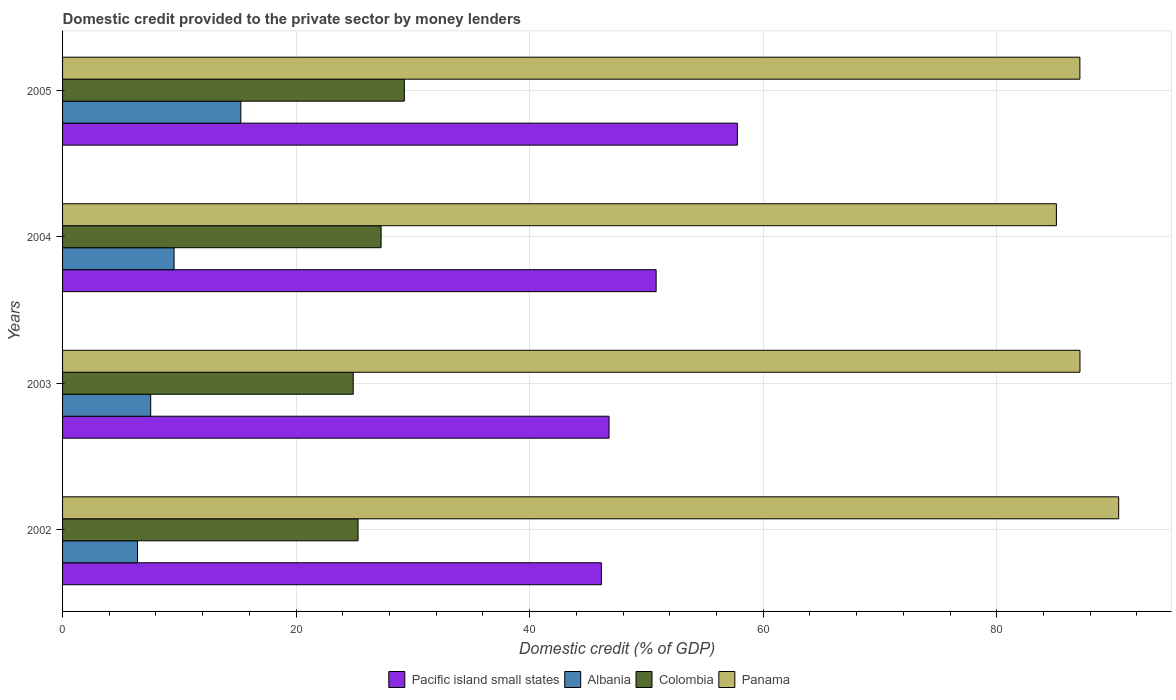How many groups of bars are there?
Make the answer very short. 4. How many bars are there on the 3rd tick from the bottom?
Ensure brevity in your answer.  4. In how many cases, is the number of bars for a given year not equal to the number of legend labels?
Provide a short and direct response. 0. What is the domestic credit provided to the private sector by money lenders in Panama in 2002?
Keep it short and to the point. 90.44. Across all years, what is the maximum domestic credit provided to the private sector by money lenders in Colombia?
Provide a succinct answer. 29.27. Across all years, what is the minimum domestic credit provided to the private sector by money lenders in Albania?
Offer a very short reply. 6.42. In which year was the domestic credit provided to the private sector by money lenders in Albania minimum?
Offer a terse response. 2002. What is the total domestic credit provided to the private sector by money lenders in Panama in the graph?
Give a very brief answer. 349.78. What is the difference between the domestic credit provided to the private sector by money lenders in Colombia in 2002 and that in 2003?
Provide a succinct answer. 0.41. What is the difference between the domestic credit provided to the private sector by money lenders in Pacific island small states in 2004 and the domestic credit provided to the private sector by money lenders in Albania in 2005?
Your response must be concise. 35.57. What is the average domestic credit provided to the private sector by money lenders in Pacific island small states per year?
Your answer should be compact. 50.39. In the year 2005, what is the difference between the domestic credit provided to the private sector by money lenders in Colombia and domestic credit provided to the private sector by money lenders in Albania?
Your answer should be very brief. 14. In how many years, is the domestic credit provided to the private sector by money lenders in Colombia greater than 88 %?
Your answer should be compact. 0. What is the ratio of the domestic credit provided to the private sector by money lenders in Colombia in 2003 to that in 2004?
Keep it short and to the point. 0.91. Is the domestic credit provided to the private sector by money lenders in Pacific island small states in 2004 less than that in 2005?
Your answer should be very brief. Yes. What is the difference between the highest and the second highest domestic credit provided to the private sector by money lenders in Albania?
Offer a very short reply. 5.71. What is the difference between the highest and the lowest domestic credit provided to the private sector by money lenders in Panama?
Keep it short and to the point. 5.33. In how many years, is the domestic credit provided to the private sector by money lenders in Colombia greater than the average domestic credit provided to the private sector by money lenders in Colombia taken over all years?
Offer a terse response. 2. Is it the case that in every year, the sum of the domestic credit provided to the private sector by money lenders in Panama and domestic credit provided to the private sector by money lenders in Pacific island small states is greater than the sum of domestic credit provided to the private sector by money lenders in Colombia and domestic credit provided to the private sector by money lenders in Albania?
Keep it short and to the point. Yes. What does the 4th bar from the top in 2003 represents?
Ensure brevity in your answer.  Pacific island small states. What does the 3rd bar from the bottom in 2004 represents?
Offer a terse response. Colombia. Is it the case that in every year, the sum of the domestic credit provided to the private sector by money lenders in Panama and domestic credit provided to the private sector by money lenders in Pacific island small states is greater than the domestic credit provided to the private sector by money lenders in Colombia?
Your answer should be very brief. Yes. How many years are there in the graph?
Provide a succinct answer. 4. Are the values on the major ticks of X-axis written in scientific E-notation?
Keep it short and to the point. No. Where does the legend appear in the graph?
Provide a succinct answer. Bottom center. How are the legend labels stacked?
Provide a short and direct response. Horizontal. What is the title of the graph?
Ensure brevity in your answer.  Domestic credit provided to the private sector by money lenders. What is the label or title of the X-axis?
Your answer should be compact. Domestic credit (% of GDP). What is the Domestic credit (% of GDP) in Pacific island small states in 2002?
Your answer should be compact. 46.14. What is the Domestic credit (% of GDP) in Albania in 2002?
Your response must be concise. 6.42. What is the Domestic credit (% of GDP) in Colombia in 2002?
Your response must be concise. 25.3. What is the Domestic credit (% of GDP) in Panama in 2002?
Provide a short and direct response. 90.44. What is the Domestic credit (% of GDP) in Pacific island small states in 2003?
Offer a very short reply. 46.8. What is the Domestic credit (% of GDP) in Albania in 2003?
Ensure brevity in your answer.  7.55. What is the Domestic credit (% of GDP) of Colombia in 2003?
Ensure brevity in your answer.  24.89. What is the Domestic credit (% of GDP) of Panama in 2003?
Offer a terse response. 87.12. What is the Domestic credit (% of GDP) in Pacific island small states in 2004?
Your answer should be very brief. 50.83. What is the Domestic credit (% of GDP) of Albania in 2004?
Your answer should be compact. 9.55. What is the Domestic credit (% of GDP) of Colombia in 2004?
Your answer should be compact. 27.28. What is the Domestic credit (% of GDP) of Panama in 2004?
Make the answer very short. 85.11. What is the Domestic credit (% of GDP) in Pacific island small states in 2005?
Keep it short and to the point. 57.79. What is the Domestic credit (% of GDP) of Albania in 2005?
Your response must be concise. 15.26. What is the Domestic credit (% of GDP) in Colombia in 2005?
Your answer should be very brief. 29.27. What is the Domestic credit (% of GDP) in Panama in 2005?
Provide a short and direct response. 87.12. Across all years, what is the maximum Domestic credit (% of GDP) in Pacific island small states?
Your response must be concise. 57.79. Across all years, what is the maximum Domestic credit (% of GDP) in Albania?
Offer a terse response. 15.26. Across all years, what is the maximum Domestic credit (% of GDP) in Colombia?
Give a very brief answer. 29.27. Across all years, what is the maximum Domestic credit (% of GDP) of Panama?
Offer a terse response. 90.44. Across all years, what is the minimum Domestic credit (% of GDP) in Pacific island small states?
Keep it short and to the point. 46.14. Across all years, what is the minimum Domestic credit (% of GDP) in Albania?
Provide a succinct answer. 6.42. Across all years, what is the minimum Domestic credit (% of GDP) in Colombia?
Your response must be concise. 24.89. Across all years, what is the minimum Domestic credit (% of GDP) in Panama?
Provide a succinct answer. 85.11. What is the total Domestic credit (% of GDP) in Pacific island small states in the graph?
Keep it short and to the point. 201.56. What is the total Domestic credit (% of GDP) in Albania in the graph?
Give a very brief answer. 38.78. What is the total Domestic credit (% of GDP) in Colombia in the graph?
Make the answer very short. 106.74. What is the total Domestic credit (% of GDP) of Panama in the graph?
Make the answer very short. 349.78. What is the difference between the Domestic credit (% of GDP) of Pacific island small states in 2002 and that in 2003?
Ensure brevity in your answer.  -0.65. What is the difference between the Domestic credit (% of GDP) of Albania in 2002 and that in 2003?
Give a very brief answer. -1.13. What is the difference between the Domestic credit (% of GDP) of Colombia in 2002 and that in 2003?
Provide a succinct answer. 0.41. What is the difference between the Domestic credit (% of GDP) of Panama in 2002 and that in 2003?
Your answer should be compact. 3.32. What is the difference between the Domestic credit (% of GDP) in Pacific island small states in 2002 and that in 2004?
Your answer should be compact. -4.69. What is the difference between the Domestic credit (% of GDP) in Albania in 2002 and that in 2004?
Ensure brevity in your answer.  -3.13. What is the difference between the Domestic credit (% of GDP) in Colombia in 2002 and that in 2004?
Keep it short and to the point. -1.97. What is the difference between the Domestic credit (% of GDP) in Panama in 2002 and that in 2004?
Your answer should be compact. 5.33. What is the difference between the Domestic credit (% of GDP) in Pacific island small states in 2002 and that in 2005?
Keep it short and to the point. -11.64. What is the difference between the Domestic credit (% of GDP) in Albania in 2002 and that in 2005?
Keep it short and to the point. -8.84. What is the difference between the Domestic credit (% of GDP) of Colombia in 2002 and that in 2005?
Your response must be concise. -3.96. What is the difference between the Domestic credit (% of GDP) of Panama in 2002 and that in 2005?
Keep it short and to the point. 3.32. What is the difference between the Domestic credit (% of GDP) in Pacific island small states in 2003 and that in 2004?
Ensure brevity in your answer.  -4.03. What is the difference between the Domestic credit (% of GDP) of Albania in 2003 and that in 2004?
Provide a short and direct response. -2. What is the difference between the Domestic credit (% of GDP) of Colombia in 2003 and that in 2004?
Give a very brief answer. -2.39. What is the difference between the Domestic credit (% of GDP) of Panama in 2003 and that in 2004?
Ensure brevity in your answer.  2.02. What is the difference between the Domestic credit (% of GDP) of Pacific island small states in 2003 and that in 2005?
Give a very brief answer. -10.99. What is the difference between the Domestic credit (% of GDP) in Albania in 2003 and that in 2005?
Ensure brevity in your answer.  -7.72. What is the difference between the Domestic credit (% of GDP) of Colombia in 2003 and that in 2005?
Ensure brevity in your answer.  -4.38. What is the difference between the Domestic credit (% of GDP) in Panama in 2003 and that in 2005?
Offer a very short reply. 0.01. What is the difference between the Domestic credit (% of GDP) in Pacific island small states in 2004 and that in 2005?
Make the answer very short. -6.96. What is the difference between the Domestic credit (% of GDP) in Albania in 2004 and that in 2005?
Ensure brevity in your answer.  -5.71. What is the difference between the Domestic credit (% of GDP) of Colombia in 2004 and that in 2005?
Offer a terse response. -1.99. What is the difference between the Domestic credit (% of GDP) of Panama in 2004 and that in 2005?
Provide a short and direct response. -2.01. What is the difference between the Domestic credit (% of GDP) of Pacific island small states in 2002 and the Domestic credit (% of GDP) of Albania in 2003?
Provide a short and direct response. 38.6. What is the difference between the Domestic credit (% of GDP) of Pacific island small states in 2002 and the Domestic credit (% of GDP) of Colombia in 2003?
Offer a very short reply. 21.25. What is the difference between the Domestic credit (% of GDP) in Pacific island small states in 2002 and the Domestic credit (% of GDP) in Panama in 2003?
Offer a very short reply. -40.98. What is the difference between the Domestic credit (% of GDP) of Albania in 2002 and the Domestic credit (% of GDP) of Colombia in 2003?
Give a very brief answer. -18.47. What is the difference between the Domestic credit (% of GDP) of Albania in 2002 and the Domestic credit (% of GDP) of Panama in 2003?
Your answer should be compact. -80.7. What is the difference between the Domestic credit (% of GDP) of Colombia in 2002 and the Domestic credit (% of GDP) of Panama in 2003?
Your answer should be compact. -61.82. What is the difference between the Domestic credit (% of GDP) of Pacific island small states in 2002 and the Domestic credit (% of GDP) of Albania in 2004?
Provide a short and direct response. 36.59. What is the difference between the Domestic credit (% of GDP) of Pacific island small states in 2002 and the Domestic credit (% of GDP) of Colombia in 2004?
Provide a short and direct response. 18.87. What is the difference between the Domestic credit (% of GDP) in Pacific island small states in 2002 and the Domestic credit (% of GDP) in Panama in 2004?
Make the answer very short. -38.96. What is the difference between the Domestic credit (% of GDP) of Albania in 2002 and the Domestic credit (% of GDP) of Colombia in 2004?
Provide a short and direct response. -20.86. What is the difference between the Domestic credit (% of GDP) in Albania in 2002 and the Domestic credit (% of GDP) in Panama in 2004?
Make the answer very short. -78.69. What is the difference between the Domestic credit (% of GDP) of Colombia in 2002 and the Domestic credit (% of GDP) of Panama in 2004?
Give a very brief answer. -59.8. What is the difference between the Domestic credit (% of GDP) of Pacific island small states in 2002 and the Domestic credit (% of GDP) of Albania in 2005?
Provide a short and direct response. 30.88. What is the difference between the Domestic credit (% of GDP) in Pacific island small states in 2002 and the Domestic credit (% of GDP) in Colombia in 2005?
Your answer should be very brief. 16.88. What is the difference between the Domestic credit (% of GDP) in Pacific island small states in 2002 and the Domestic credit (% of GDP) in Panama in 2005?
Offer a terse response. -40.97. What is the difference between the Domestic credit (% of GDP) in Albania in 2002 and the Domestic credit (% of GDP) in Colombia in 2005?
Offer a very short reply. -22.85. What is the difference between the Domestic credit (% of GDP) in Albania in 2002 and the Domestic credit (% of GDP) in Panama in 2005?
Offer a very short reply. -80.7. What is the difference between the Domestic credit (% of GDP) in Colombia in 2002 and the Domestic credit (% of GDP) in Panama in 2005?
Make the answer very short. -61.81. What is the difference between the Domestic credit (% of GDP) in Pacific island small states in 2003 and the Domestic credit (% of GDP) in Albania in 2004?
Your response must be concise. 37.25. What is the difference between the Domestic credit (% of GDP) of Pacific island small states in 2003 and the Domestic credit (% of GDP) of Colombia in 2004?
Offer a terse response. 19.52. What is the difference between the Domestic credit (% of GDP) in Pacific island small states in 2003 and the Domestic credit (% of GDP) in Panama in 2004?
Your answer should be compact. -38.31. What is the difference between the Domestic credit (% of GDP) in Albania in 2003 and the Domestic credit (% of GDP) in Colombia in 2004?
Provide a succinct answer. -19.73. What is the difference between the Domestic credit (% of GDP) in Albania in 2003 and the Domestic credit (% of GDP) in Panama in 2004?
Your response must be concise. -77.56. What is the difference between the Domestic credit (% of GDP) in Colombia in 2003 and the Domestic credit (% of GDP) in Panama in 2004?
Offer a terse response. -60.21. What is the difference between the Domestic credit (% of GDP) of Pacific island small states in 2003 and the Domestic credit (% of GDP) of Albania in 2005?
Your response must be concise. 31.53. What is the difference between the Domestic credit (% of GDP) in Pacific island small states in 2003 and the Domestic credit (% of GDP) in Colombia in 2005?
Provide a short and direct response. 17.53. What is the difference between the Domestic credit (% of GDP) in Pacific island small states in 2003 and the Domestic credit (% of GDP) in Panama in 2005?
Provide a short and direct response. -40.32. What is the difference between the Domestic credit (% of GDP) in Albania in 2003 and the Domestic credit (% of GDP) in Colombia in 2005?
Ensure brevity in your answer.  -21.72. What is the difference between the Domestic credit (% of GDP) of Albania in 2003 and the Domestic credit (% of GDP) of Panama in 2005?
Give a very brief answer. -79.57. What is the difference between the Domestic credit (% of GDP) of Colombia in 2003 and the Domestic credit (% of GDP) of Panama in 2005?
Your answer should be very brief. -62.23. What is the difference between the Domestic credit (% of GDP) of Pacific island small states in 2004 and the Domestic credit (% of GDP) of Albania in 2005?
Make the answer very short. 35.57. What is the difference between the Domestic credit (% of GDP) in Pacific island small states in 2004 and the Domestic credit (% of GDP) in Colombia in 2005?
Your response must be concise. 21.56. What is the difference between the Domestic credit (% of GDP) of Pacific island small states in 2004 and the Domestic credit (% of GDP) of Panama in 2005?
Your answer should be very brief. -36.29. What is the difference between the Domestic credit (% of GDP) of Albania in 2004 and the Domestic credit (% of GDP) of Colombia in 2005?
Your answer should be very brief. -19.72. What is the difference between the Domestic credit (% of GDP) in Albania in 2004 and the Domestic credit (% of GDP) in Panama in 2005?
Offer a terse response. -77.57. What is the difference between the Domestic credit (% of GDP) in Colombia in 2004 and the Domestic credit (% of GDP) in Panama in 2005?
Offer a terse response. -59.84. What is the average Domestic credit (% of GDP) of Pacific island small states per year?
Your answer should be compact. 50.39. What is the average Domestic credit (% of GDP) in Albania per year?
Give a very brief answer. 9.69. What is the average Domestic credit (% of GDP) in Colombia per year?
Your response must be concise. 26.68. What is the average Domestic credit (% of GDP) of Panama per year?
Ensure brevity in your answer.  87.45. In the year 2002, what is the difference between the Domestic credit (% of GDP) of Pacific island small states and Domestic credit (% of GDP) of Albania?
Offer a very short reply. 39.72. In the year 2002, what is the difference between the Domestic credit (% of GDP) in Pacific island small states and Domestic credit (% of GDP) in Colombia?
Provide a short and direct response. 20.84. In the year 2002, what is the difference between the Domestic credit (% of GDP) of Pacific island small states and Domestic credit (% of GDP) of Panama?
Give a very brief answer. -44.3. In the year 2002, what is the difference between the Domestic credit (% of GDP) in Albania and Domestic credit (% of GDP) in Colombia?
Give a very brief answer. -18.88. In the year 2002, what is the difference between the Domestic credit (% of GDP) in Albania and Domestic credit (% of GDP) in Panama?
Provide a short and direct response. -84.02. In the year 2002, what is the difference between the Domestic credit (% of GDP) of Colombia and Domestic credit (% of GDP) of Panama?
Your response must be concise. -65.14. In the year 2003, what is the difference between the Domestic credit (% of GDP) in Pacific island small states and Domestic credit (% of GDP) in Albania?
Provide a succinct answer. 39.25. In the year 2003, what is the difference between the Domestic credit (% of GDP) in Pacific island small states and Domestic credit (% of GDP) in Colombia?
Give a very brief answer. 21.91. In the year 2003, what is the difference between the Domestic credit (% of GDP) in Pacific island small states and Domestic credit (% of GDP) in Panama?
Provide a short and direct response. -40.32. In the year 2003, what is the difference between the Domestic credit (% of GDP) of Albania and Domestic credit (% of GDP) of Colombia?
Your answer should be very brief. -17.34. In the year 2003, what is the difference between the Domestic credit (% of GDP) of Albania and Domestic credit (% of GDP) of Panama?
Your response must be concise. -79.57. In the year 2003, what is the difference between the Domestic credit (% of GDP) in Colombia and Domestic credit (% of GDP) in Panama?
Make the answer very short. -62.23. In the year 2004, what is the difference between the Domestic credit (% of GDP) in Pacific island small states and Domestic credit (% of GDP) in Albania?
Your response must be concise. 41.28. In the year 2004, what is the difference between the Domestic credit (% of GDP) of Pacific island small states and Domestic credit (% of GDP) of Colombia?
Offer a very short reply. 23.55. In the year 2004, what is the difference between the Domestic credit (% of GDP) in Pacific island small states and Domestic credit (% of GDP) in Panama?
Give a very brief answer. -34.28. In the year 2004, what is the difference between the Domestic credit (% of GDP) of Albania and Domestic credit (% of GDP) of Colombia?
Your answer should be compact. -17.73. In the year 2004, what is the difference between the Domestic credit (% of GDP) of Albania and Domestic credit (% of GDP) of Panama?
Offer a terse response. -75.56. In the year 2004, what is the difference between the Domestic credit (% of GDP) in Colombia and Domestic credit (% of GDP) in Panama?
Make the answer very short. -57.83. In the year 2005, what is the difference between the Domestic credit (% of GDP) in Pacific island small states and Domestic credit (% of GDP) in Albania?
Give a very brief answer. 42.52. In the year 2005, what is the difference between the Domestic credit (% of GDP) of Pacific island small states and Domestic credit (% of GDP) of Colombia?
Offer a terse response. 28.52. In the year 2005, what is the difference between the Domestic credit (% of GDP) of Pacific island small states and Domestic credit (% of GDP) of Panama?
Ensure brevity in your answer.  -29.33. In the year 2005, what is the difference between the Domestic credit (% of GDP) of Albania and Domestic credit (% of GDP) of Colombia?
Ensure brevity in your answer.  -14. In the year 2005, what is the difference between the Domestic credit (% of GDP) in Albania and Domestic credit (% of GDP) in Panama?
Keep it short and to the point. -71.85. In the year 2005, what is the difference between the Domestic credit (% of GDP) of Colombia and Domestic credit (% of GDP) of Panama?
Keep it short and to the point. -57.85. What is the ratio of the Domestic credit (% of GDP) in Albania in 2002 to that in 2003?
Offer a very short reply. 0.85. What is the ratio of the Domestic credit (% of GDP) in Colombia in 2002 to that in 2003?
Give a very brief answer. 1.02. What is the ratio of the Domestic credit (% of GDP) in Panama in 2002 to that in 2003?
Ensure brevity in your answer.  1.04. What is the ratio of the Domestic credit (% of GDP) in Pacific island small states in 2002 to that in 2004?
Your answer should be very brief. 0.91. What is the ratio of the Domestic credit (% of GDP) in Albania in 2002 to that in 2004?
Your answer should be compact. 0.67. What is the ratio of the Domestic credit (% of GDP) of Colombia in 2002 to that in 2004?
Make the answer very short. 0.93. What is the ratio of the Domestic credit (% of GDP) of Panama in 2002 to that in 2004?
Offer a terse response. 1.06. What is the ratio of the Domestic credit (% of GDP) of Pacific island small states in 2002 to that in 2005?
Keep it short and to the point. 0.8. What is the ratio of the Domestic credit (% of GDP) in Albania in 2002 to that in 2005?
Provide a succinct answer. 0.42. What is the ratio of the Domestic credit (% of GDP) of Colombia in 2002 to that in 2005?
Provide a short and direct response. 0.86. What is the ratio of the Domestic credit (% of GDP) of Panama in 2002 to that in 2005?
Offer a very short reply. 1.04. What is the ratio of the Domestic credit (% of GDP) in Pacific island small states in 2003 to that in 2004?
Your response must be concise. 0.92. What is the ratio of the Domestic credit (% of GDP) in Albania in 2003 to that in 2004?
Make the answer very short. 0.79. What is the ratio of the Domestic credit (% of GDP) of Colombia in 2003 to that in 2004?
Provide a short and direct response. 0.91. What is the ratio of the Domestic credit (% of GDP) in Panama in 2003 to that in 2004?
Your answer should be compact. 1.02. What is the ratio of the Domestic credit (% of GDP) in Pacific island small states in 2003 to that in 2005?
Provide a short and direct response. 0.81. What is the ratio of the Domestic credit (% of GDP) in Albania in 2003 to that in 2005?
Offer a very short reply. 0.49. What is the ratio of the Domestic credit (% of GDP) of Colombia in 2003 to that in 2005?
Your answer should be compact. 0.85. What is the ratio of the Domestic credit (% of GDP) in Panama in 2003 to that in 2005?
Provide a short and direct response. 1. What is the ratio of the Domestic credit (% of GDP) in Pacific island small states in 2004 to that in 2005?
Offer a very short reply. 0.88. What is the ratio of the Domestic credit (% of GDP) of Albania in 2004 to that in 2005?
Make the answer very short. 0.63. What is the ratio of the Domestic credit (% of GDP) in Colombia in 2004 to that in 2005?
Your answer should be very brief. 0.93. What is the ratio of the Domestic credit (% of GDP) in Panama in 2004 to that in 2005?
Your answer should be very brief. 0.98. What is the difference between the highest and the second highest Domestic credit (% of GDP) in Pacific island small states?
Your response must be concise. 6.96. What is the difference between the highest and the second highest Domestic credit (% of GDP) of Albania?
Keep it short and to the point. 5.71. What is the difference between the highest and the second highest Domestic credit (% of GDP) of Colombia?
Provide a short and direct response. 1.99. What is the difference between the highest and the second highest Domestic credit (% of GDP) in Panama?
Make the answer very short. 3.32. What is the difference between the highest and the lowest Domestic credit (% of GDP) in Pacific island small states?
Your response must be concise. 11.64. What is the difference between the highest and the lowest Domestic credit (% of GDP) in Albania?
Offer a terse response. 8.84. What is the difference between the highest and the lowest Domestic credit (% of GDP) in Colombia?
Provide a succinct answer. 4.38. What is the difference between the highest and the lowest Domestic credit (% of GDP) of Panama?
Provide a succinct answer. 5.33. 